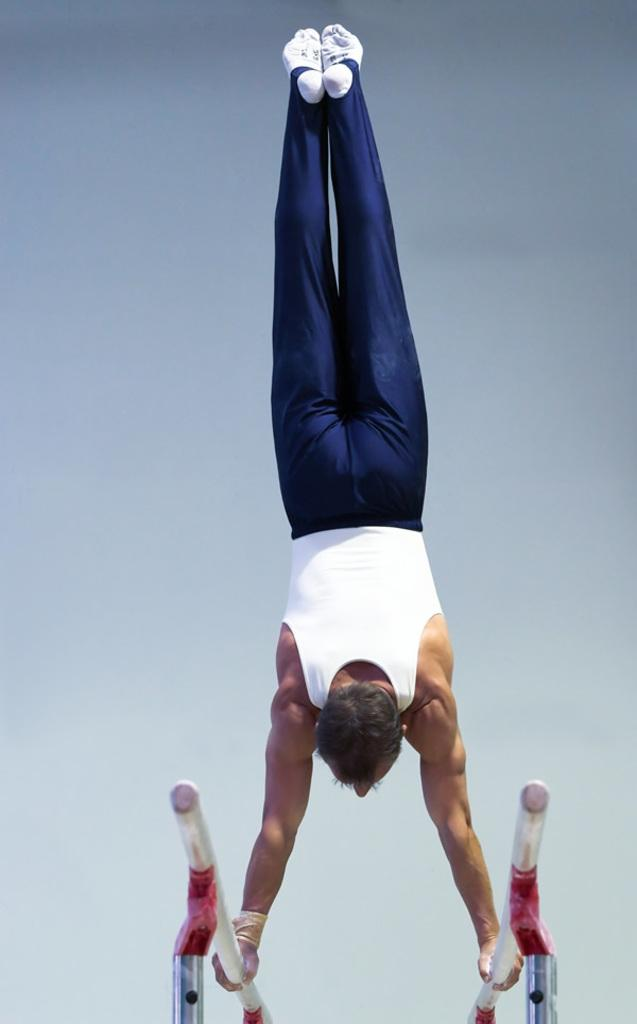What is the main subject of the image? There is a person in the image. What activity is the person engaged in? The person is doing gymnastics. How is the person positioned in the image? The person is standing upside down. What objects is the person holding in the image? The person is holding iron rods. What type of frame is visible around the person in the image? There is no frame visible around the person in the image. Can you see a fan in the image? There is no fan present in the image. 